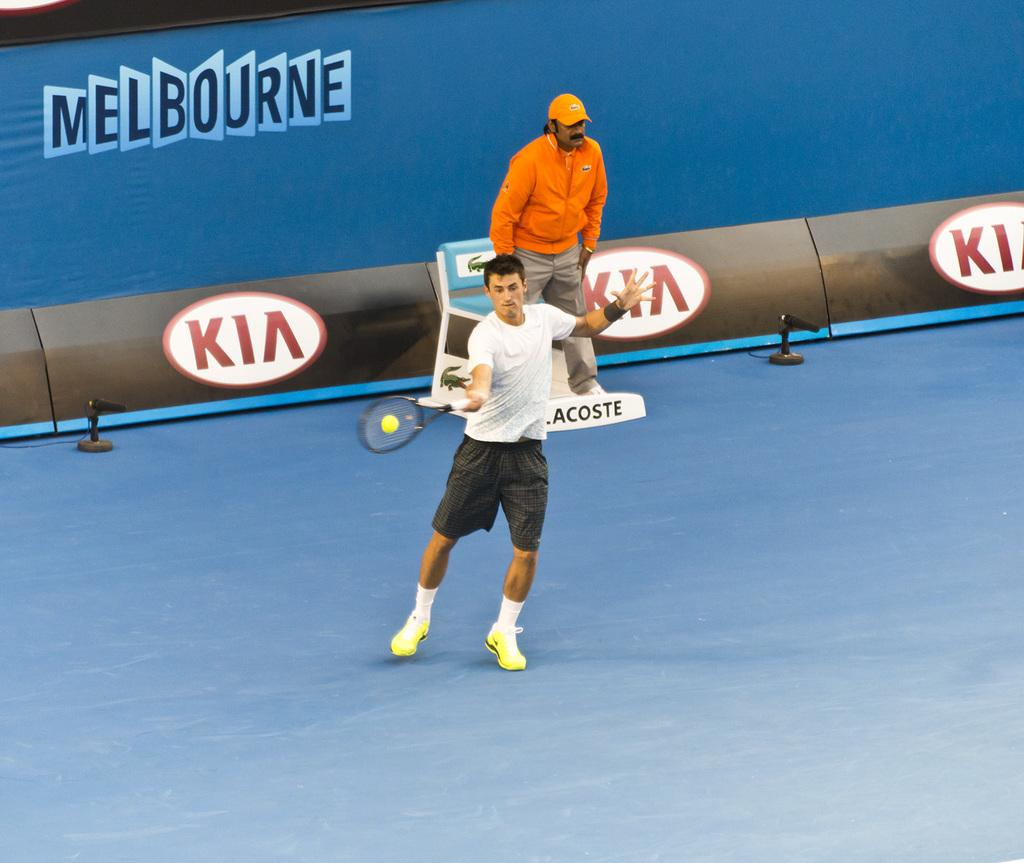How many people are in the image? There are two persons standing in the image. What is one person holding? One person is holding a bat. What is the person with the bat trying to do? The person with the bat is trying to hit a ball. What else can be seen in the image besides the people and the bat? There are banners in the image. Where is the sheep in the image? There is no sheep present in the image. What type of rail can be seen in the image? There is no rail present in the image. 